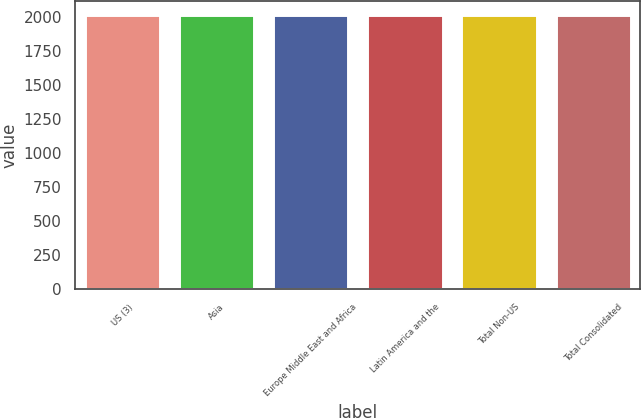<chart> <loc_0><loc_0><loc_500><loc_500><bar_chart><fcel>US (3)<fcel>Asia<fcel>Europe Middle East and Africa<fcel>Latin America and the<fcel>Total Non-US<fcel>Total Consolidated<nl><fcel>2016<fcel>2016.1<fcel>2016.2<fcel>2016.3<fcel>2016.4<fcel>2016.5<nl></chart> 